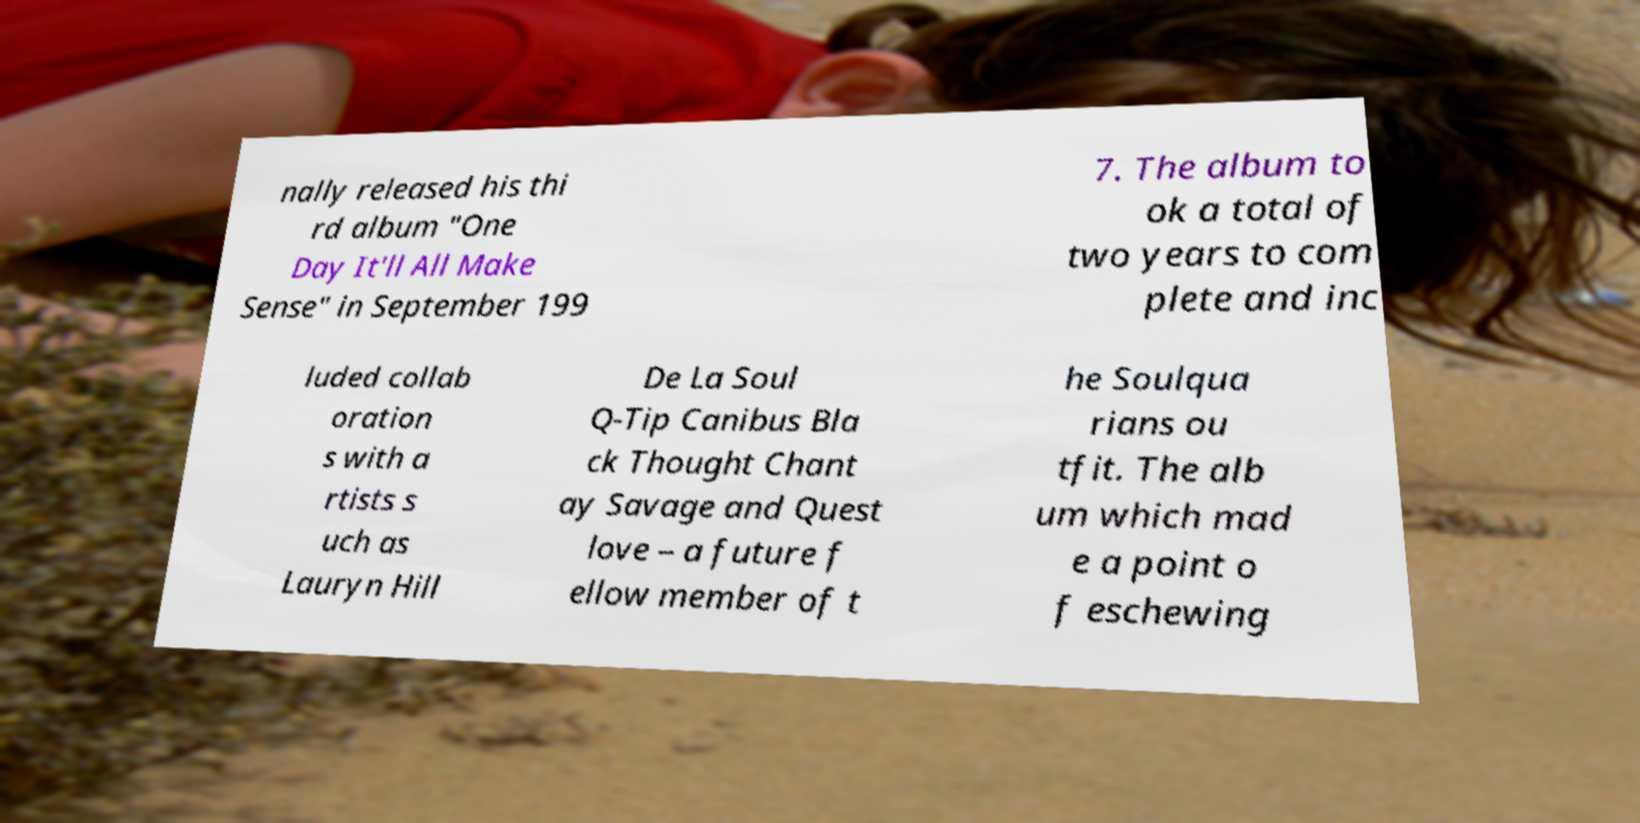Could you assist in decoding the text presented in this image and type it out clearly? nally released his thi rd album "One Day It'll All Make Sense" in September 199 7. The album to ok a total of two years to com plete and inc luded collab oration s with a rtists s uch as Lauryn Hill De La Soul Q-Tip Canibus Bla ck Thought Chant ay Savage and Quest love – a future f ellow member of t he Soulqua rians ou tfit. The alb um which mad e a point o f eschewing 